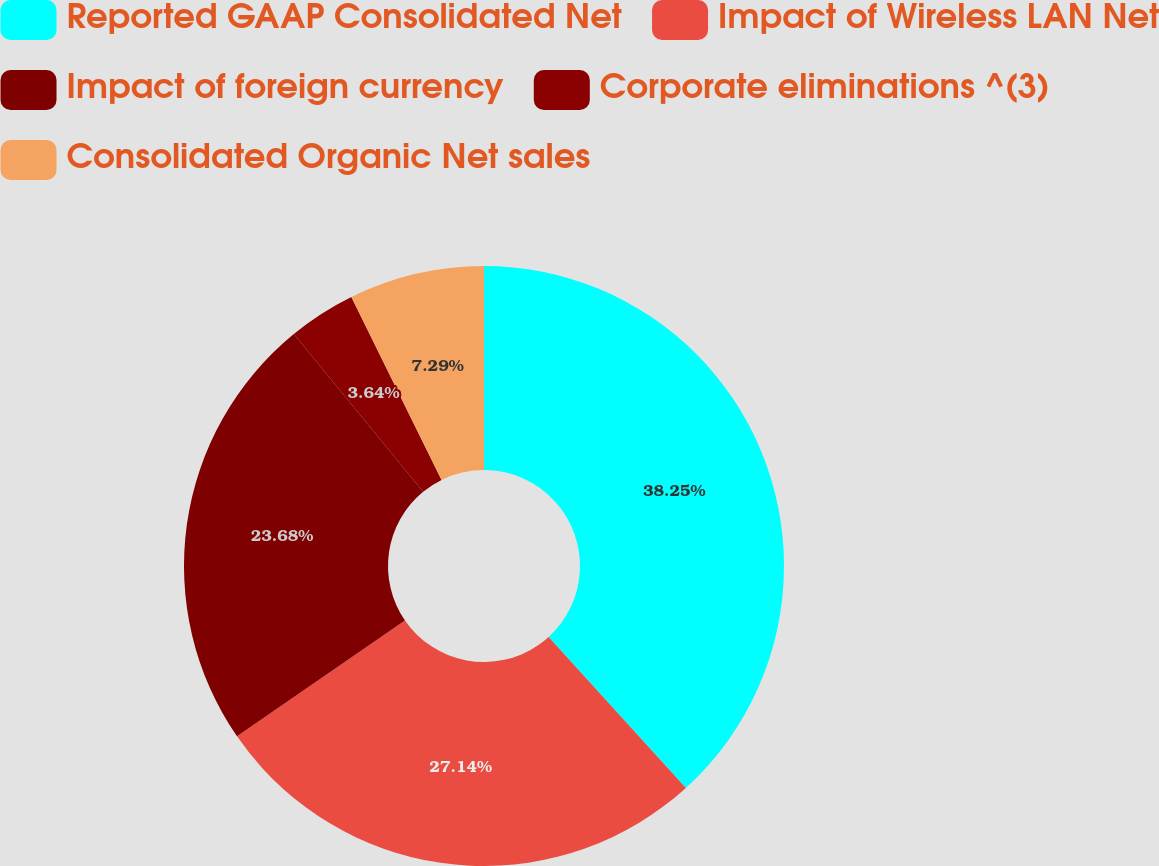Convert chart. <chart><loc_0><loc_0><loc_500><loc_500><pie_chart><fcel>Reported GAAP Consolidated Net<fcel>Impact of Wireless LAN Net<fcel>Impact of foreign currency<fcel>Corporate eliminations ^(3)<fcel>Consolidated Organic Net sales<nl><fcel>38.25%<fcel>27.14%<fcel>23.68%<fcel>3.64%<fcel>7.29%<nl></chart> 